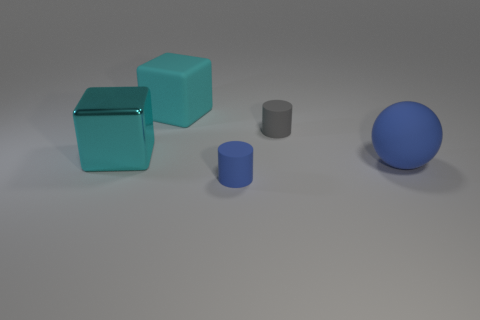What is the shape of the rubber thing that is in front of the big rubber object on the right side of the object that is behind the small gray matte thing?
Offer a terse response. Cylinder. Is there a small object that has the same material as the blue cylinder?
Your answer should be compact. Yes. Do the large rubber object to the right of the big rubber cube and the cylinder that is behind the tiny blue cylinder have the same color?
Your answer should be very brief. No. Are there fewer tiny matte cylinders that are behind the small blue thing than blocks?
Provide a succinct answer. Yes. How many objects are either cyan shiny things or objects that are in front of the large metal block?
Your response must be concise. 3. There is a ball that is the same material as the tiny blue cylinder; what color is it?
Provide a short and direct response. Blue. What number of objects are either blue matte spheres or big objects?
Give a very brief answer. 3. There is a matte sphere that is the same size as the metal block; what is its color?
Provide a succinct answer. Blue. What number of objects are either small matte objects that are to the left of the small gray rubber object or big rubber balls?
Offer a very short reply. 2. What number of other things are there of the same size as the cyan metal cube?
Make the answer very short. 2. 